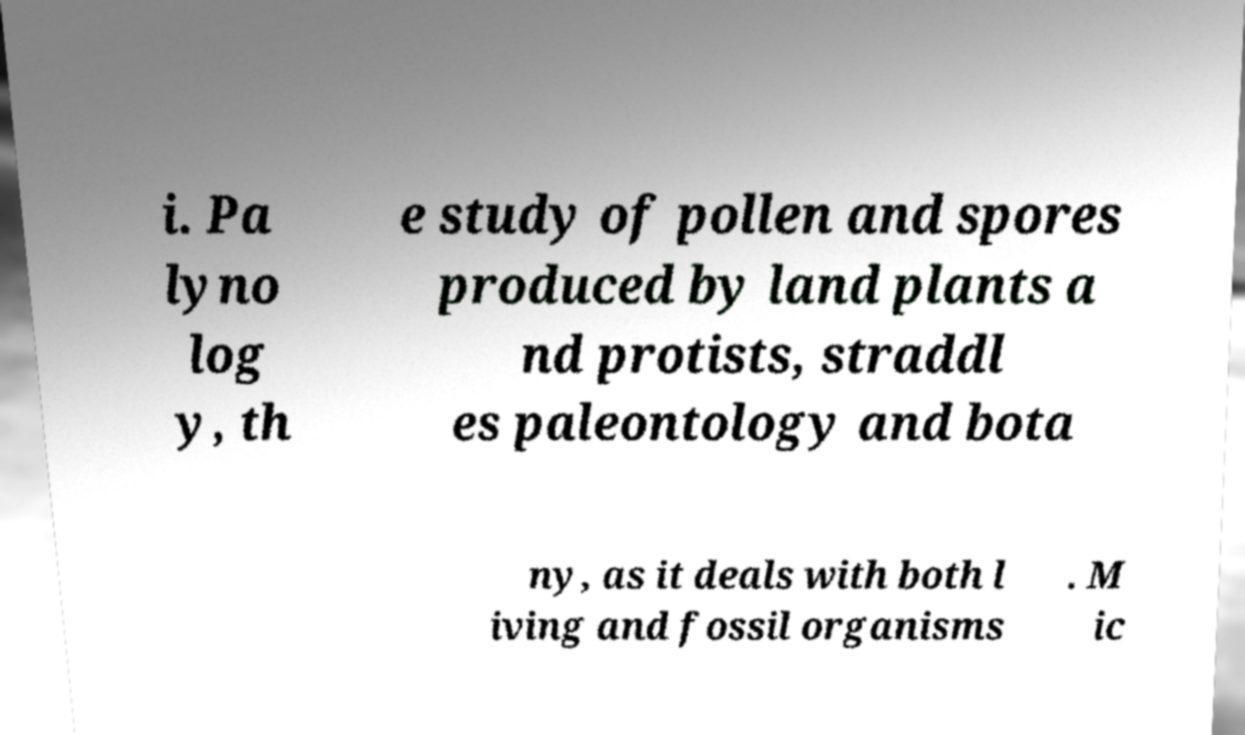Can you read and provide the text displayed in the image?This photo seems to have some interesting text. Can you extract and type it out for me? i. Pa lyno log y, th e study of pollen and spores produced by land plants a nd protists, straddl es paleontology and bota ny, as it deals with both l iving and fossil organisms . M ic 